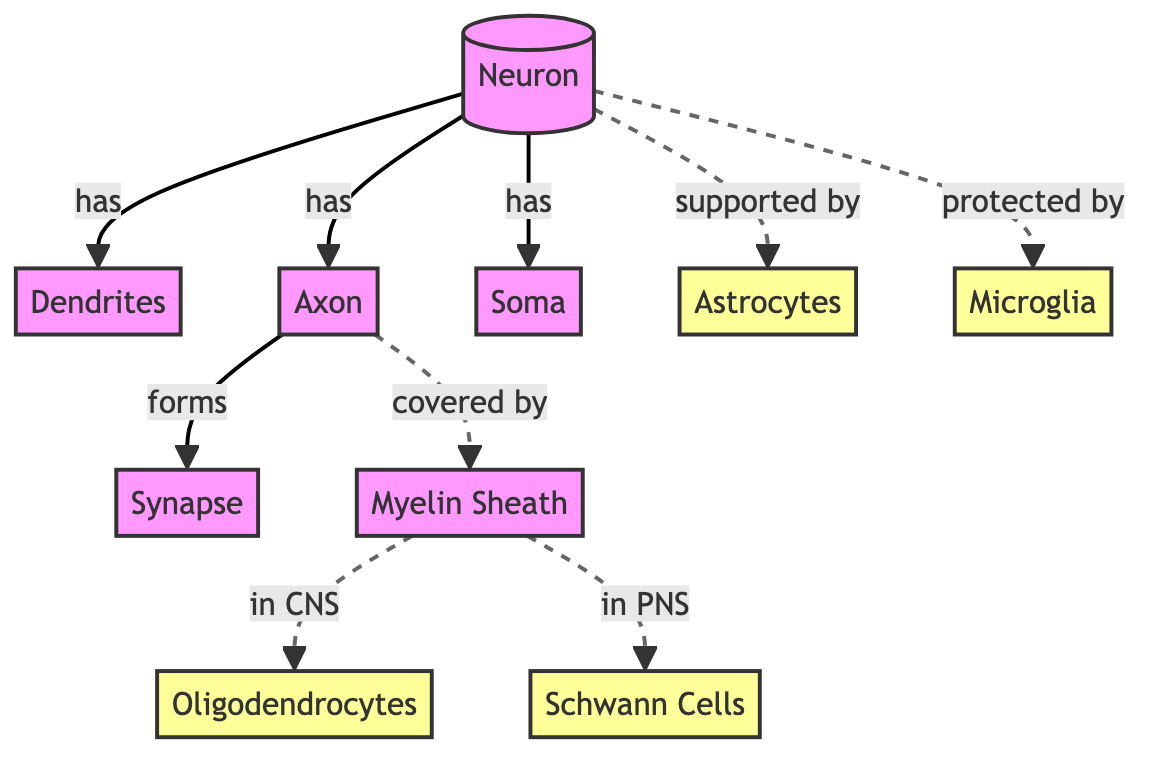What is the central component of a neuron? The diagram identifies the "Soma" as the central component of a neuron, indicated by its direct relationship with other parts like dendrites and axon.
Answer: Soma How many types of supporting cells are shown in the diagram? The diagram includes four types of supporting cells: Oligodendrocytes, Schwann Cells, Astrocytes, and Microglia. By counting these, we find a total of four.
Answer: 4 What connects the axon to a synapse? The diagram shows that the axon "forms" a synapse, indicating a direct connection from the axon to the synapse.
Answer: Synapse Which structure covers the axon in the central nervous system? The diagram indicates that the axon is "covered by" the Myelin Sheath in the CNS by referencing Oligodendrocytes specifically.
Answer: Oligodendrocytes What is the function of Astrocytes according to the diagram? Within the diagram, Astrocytes are described as "supported by" the neuron, suggesting a role in providing support and possibly nourishment to the neurons.
Answer: Support Which cells are responsible for myelination in the peripheral nervous system? The diagram specifies Schwann Cells as the entities that myelinate axons in the peripheral nervous system, indicating their direct involvement in this process.
Answer: Schwann Cells How does the diagram demonstrate the relationship between a neuron and its supporting cells? The diagram illustrates that the neuron has relationships with the supporting cells through "supported by" and "protected by" links to Astrocytes and Microglia, showing their supportive and protective functions.
Answer: Supported by, Protected by What is the relationship between axon and dendrites? The diagram shows that a neuron "has" both dendrites and axon, illustrating structural relationships suggesting that dendrites receive signals while the axon transmits them.
Answer: Has How many total relationships are depicted in the diagram? By counting each of the arrows that connect different components, the total number of relationships indicated in the diagram amounts to seven distinct connections.
Answer: 7 